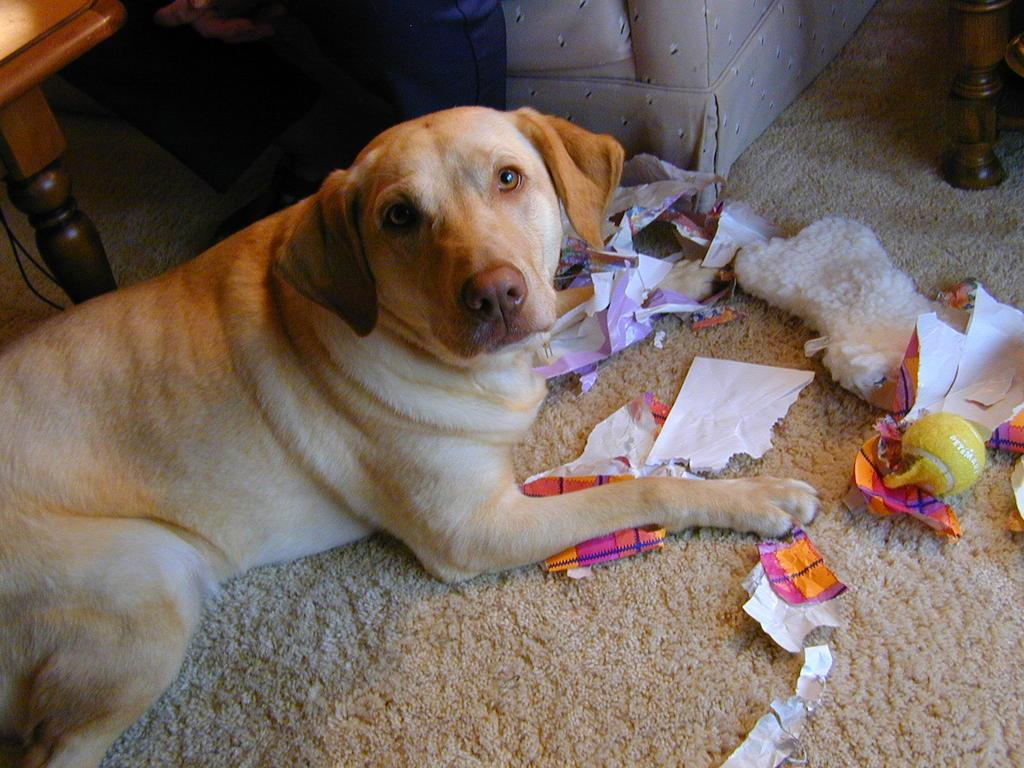What animal can be seen in the image? There is a dog in the image. Where is the dog sitting? The dog is sitting on a mat. What is in front of the dog? There are papers and other objects in front of the dog. What can be seen behind the dog? There is a couch and wooden tables behind the dog. What type of heart-shaped object can be seen in the image? There is no heart-shaped object present in the image. What kind of shade is covering the dog in the image? There is no shade covering the dog in the image; it is sitting on a mat in a well-lit area. 